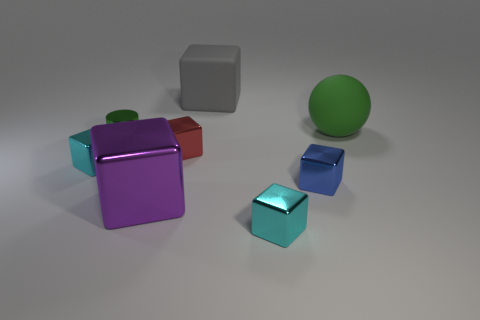What size is the purple cube that is the same material as the blue thing?
Ensure brevity in your answer.  Large. There is a tiny cylinder that is the same material as the blue block; what color is it?
Provide a succinct answer. Green. Are there any shiny blocks that have the same size as the green rubber sphere?
Your answer should be very brief. Yes. There is a big gray object that is the same shape as the purple object; what is it made of?
Ensure brevity in your answer.  Rubber. There is a red object that is the same size as the blue block; what is its shape?
Your response must be concise. Cube. Is there a large cyan rubber object that has the same shape as the green metallic object?
Your response must be concise. No. The green object to the right of the small object behind the small red thing is what shape?
Ensure brevity in your answer.  Sphere. What shape is the purple metal thing?
Your response must be concise. Cube. What is the cyan thing on the left side of the big thing to the left of the big block that is behind the big green matte ball made of?
Keep it short and to the point. Metal. What number of other things are made of the same material as the purple block?
Keep it short and to the point. 5. 